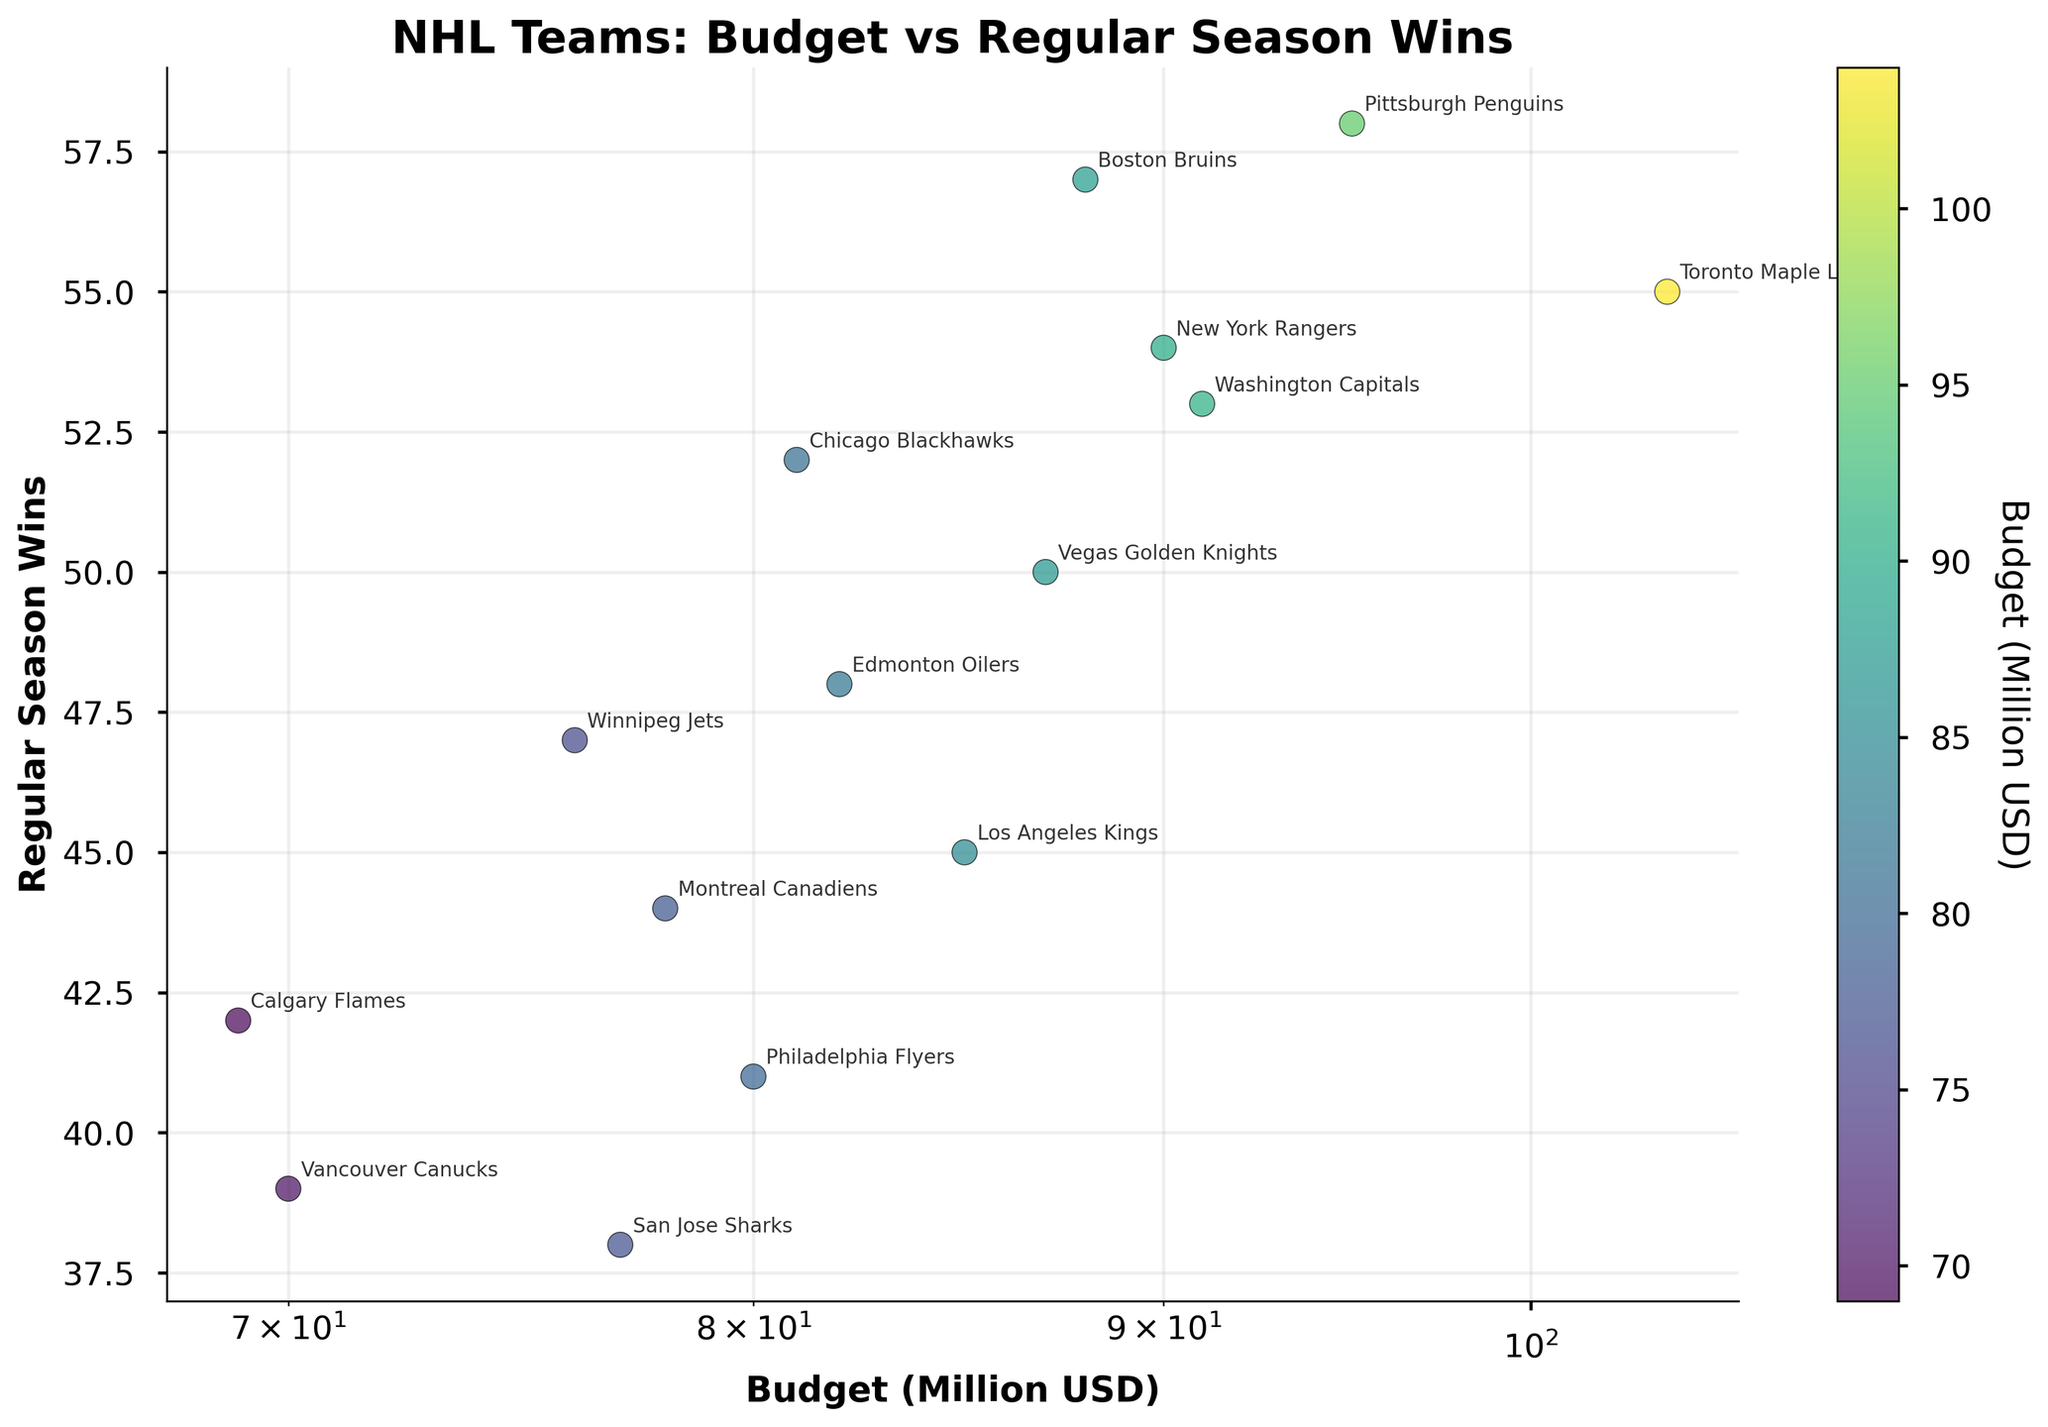Which team had the highest budget? To determine which team had the highest budget, we need to identify the point on the scatter plot with the highest x-axis value since the x-axis represents the budget.
Answer: Toronto Maple Leafs How many teams have a budget over 80 million USD? Review the points on the scatter plot to count how many are positioned beyond the 80 million mark on the x-axis, which uses a log scale.
Answer: 7 What’s the total number of regular season wins for teams with a budget below 80 million USD? Find teams with a budget below 80 million USD on the x-axis, then sum up their corresponding y-axis values. These include Vancouver Canucks (39), Calgary Flames (42), Winnipeg Jets (47), and San Jose Sharks (38). Calculating the sum, 39 + 42 + 47 + 38 = 166
Answer: 166 Which team had the least regular season wins and what was their budget? Look for the team with the lowest y-axis value and check their x-axis position to determine the budget.
Answer: San Jose Sharks, 77 million USD Do the Boston Bruins have more wins or a higher budget when compared to the Los Angeles Kings? Identify the points for both Boston Bruins and Los Angeles Kings, check their y-axis values to compare wins, and check their x-axis values to compare budgets. Boston Bruins have more wins (57 vs 45) and a higher budget (88 vs 85) than Los Angeles Kings.
Answer: More wins and higher budget Is there a positive correlation between team budgets and regular season wins? Observe the general trend of the scatter plot points. If points tend to increase on the y-axis as values on the x-axis increase, it suggests a positive correlation.
Answer: Yes Which team had a budget closest to the Winnipeg Jets, and how many wins did they get? Find the Winnipeg Jets' point and look for the team with the closest x-axis value to Winnipeg's budget of 76 million USD. The closest is San Jose Sharks with roughly the same budget. San Jose Sharks had 38 wins.
Answer: San Jose Sharks, 38 wins Which team had the most regular season wins and how does their budget compare to the average team budget? Identify the team with the highest y-axis value (Pittsburgh Penguins with 58 wins), then compare their x-axis value to the average budget. The average budget is the sum of all budgets divided by the number of teams: (104+90+81+78+88+70+69+82+76+85+87+95+91+80+77)/15 = 81.33. Pittsburgh's budget is 95, higher than the average.
Answer: Pittsburgh Penguins, higher than average What is the budget range (difference between highest and lowest budgets) of the teams depicted in the plot? Identify the highest budget (104 million USD, Toronto Maple Leafs) and the lowest budget (69 million USD, Calgary Flames), then find the difference: 104 - 69 = 35
Answer: 35 million USD 